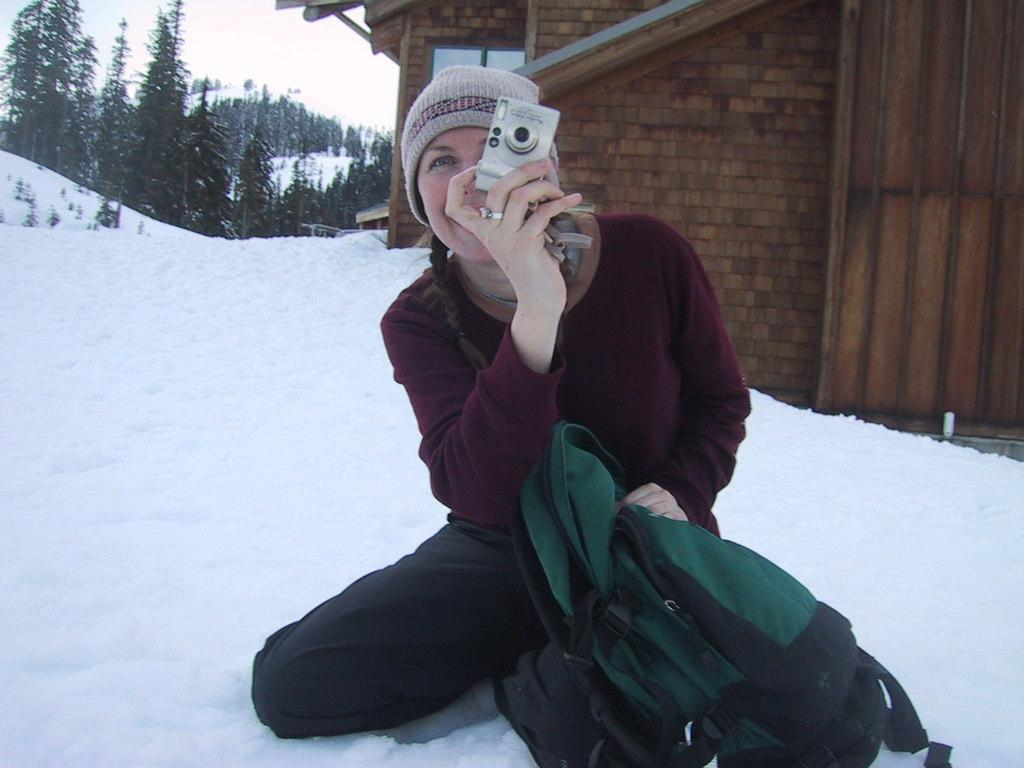Who is the main subject in the picture? There is a lady in the picture. What is the lady holding in the image? The lady is holding a camera. Where is the lady sitting in the image? The lady is sitting on the ice. What object is in front of the lady? There is a backpack in front of the lady. Can you see any ghosts in the image? There are no ghosts present in the image. What type of headwear is the lady wearing in the image? The lady is not wearing any headwear in the image. 